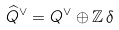Convert formula to latex. <formula><loc_0><loc_0><loc_500><loc_500>\widehat { Q } ^ { \vee } = Q ^ { \vee } \oplus \mathbb { Z } \, \delta</formula> 